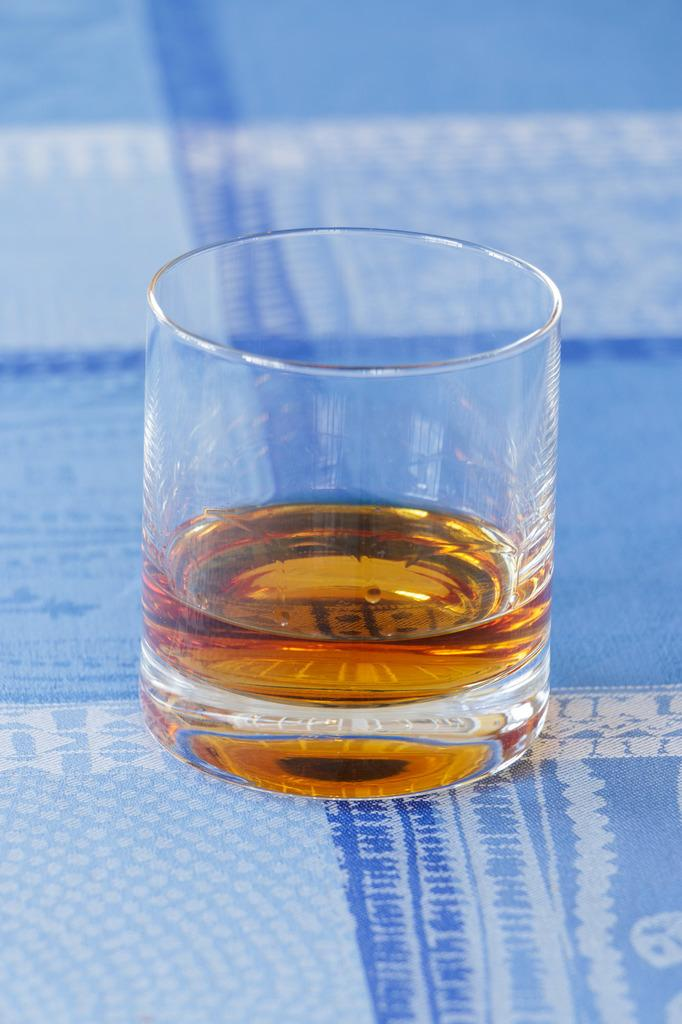What is contained in the glass that is visible in the image? There is a glass with liquid in the image. Where is the glass placed in the image? The glass is placed on a blue cloth. Can you describe the blue cloth in the image? The blue cloth has designs on it. How would you describe the background of the image? The background of the image has a blurred view. What type of minute is present in the image? There is no mention of a minute or any time-related element in the image. 